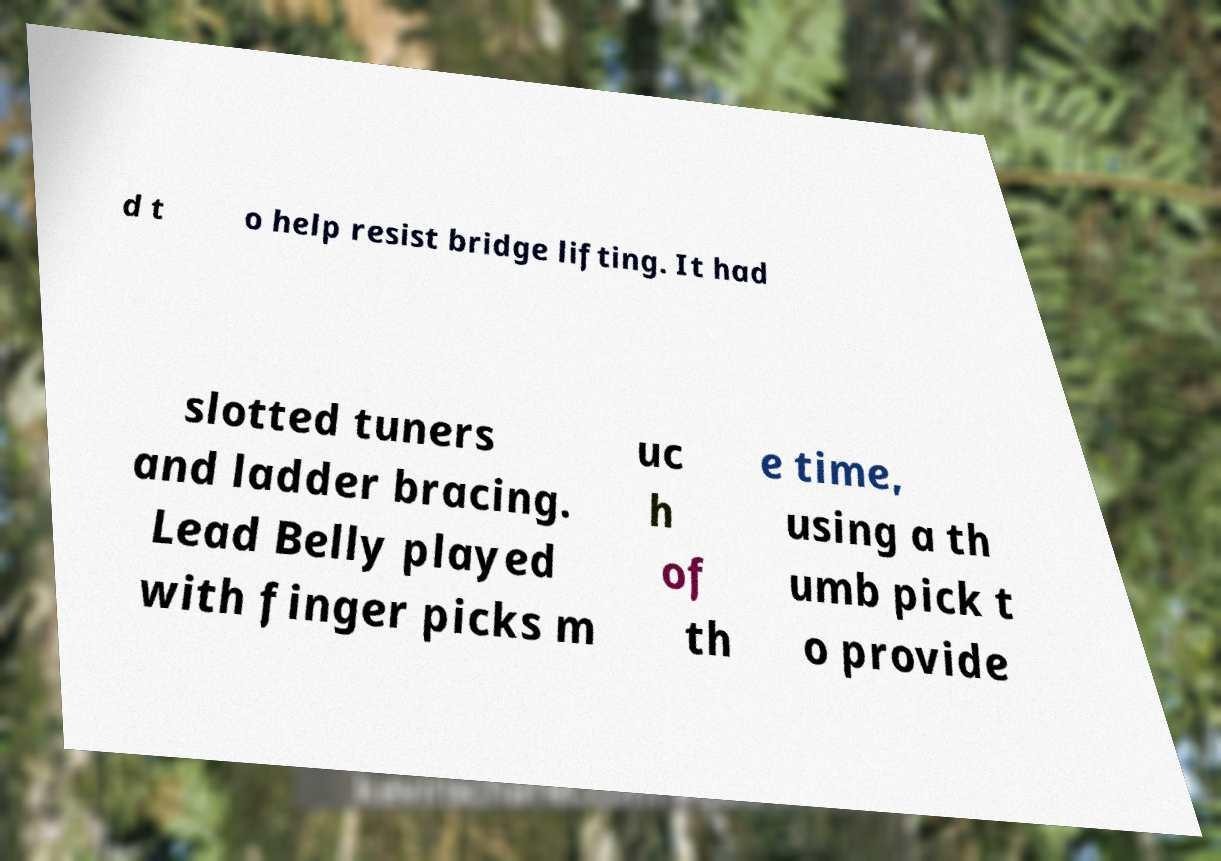Could you extract and type out the text from this image? d t o help resist bridge lifting. It had slotted tuners and ladder bracing. Lead Belly played with finger picks m uc h of th e time, using a th umb pick t o provide 